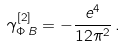<formula> <loc_0><loc_0><loc_500><loc_500>\gamma _ { \Phi \, B } ^ { [ 2 ] } = - \frac { e ^ { 4 } } { 1 2 \pi ^ { 2 } } \, .</formula> 